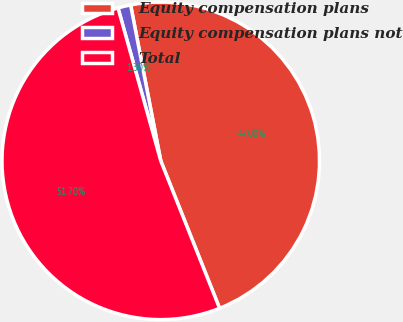<chart> <loc_0><loc_0><loc_500><loc_500><pie_chart><fcel>Equity compensation plans<fcel>Equity compensation plans not<fcel>Total<nl><fcel>47.0%<fcel>1.3%<fcel>51.7%<nl></chart> 